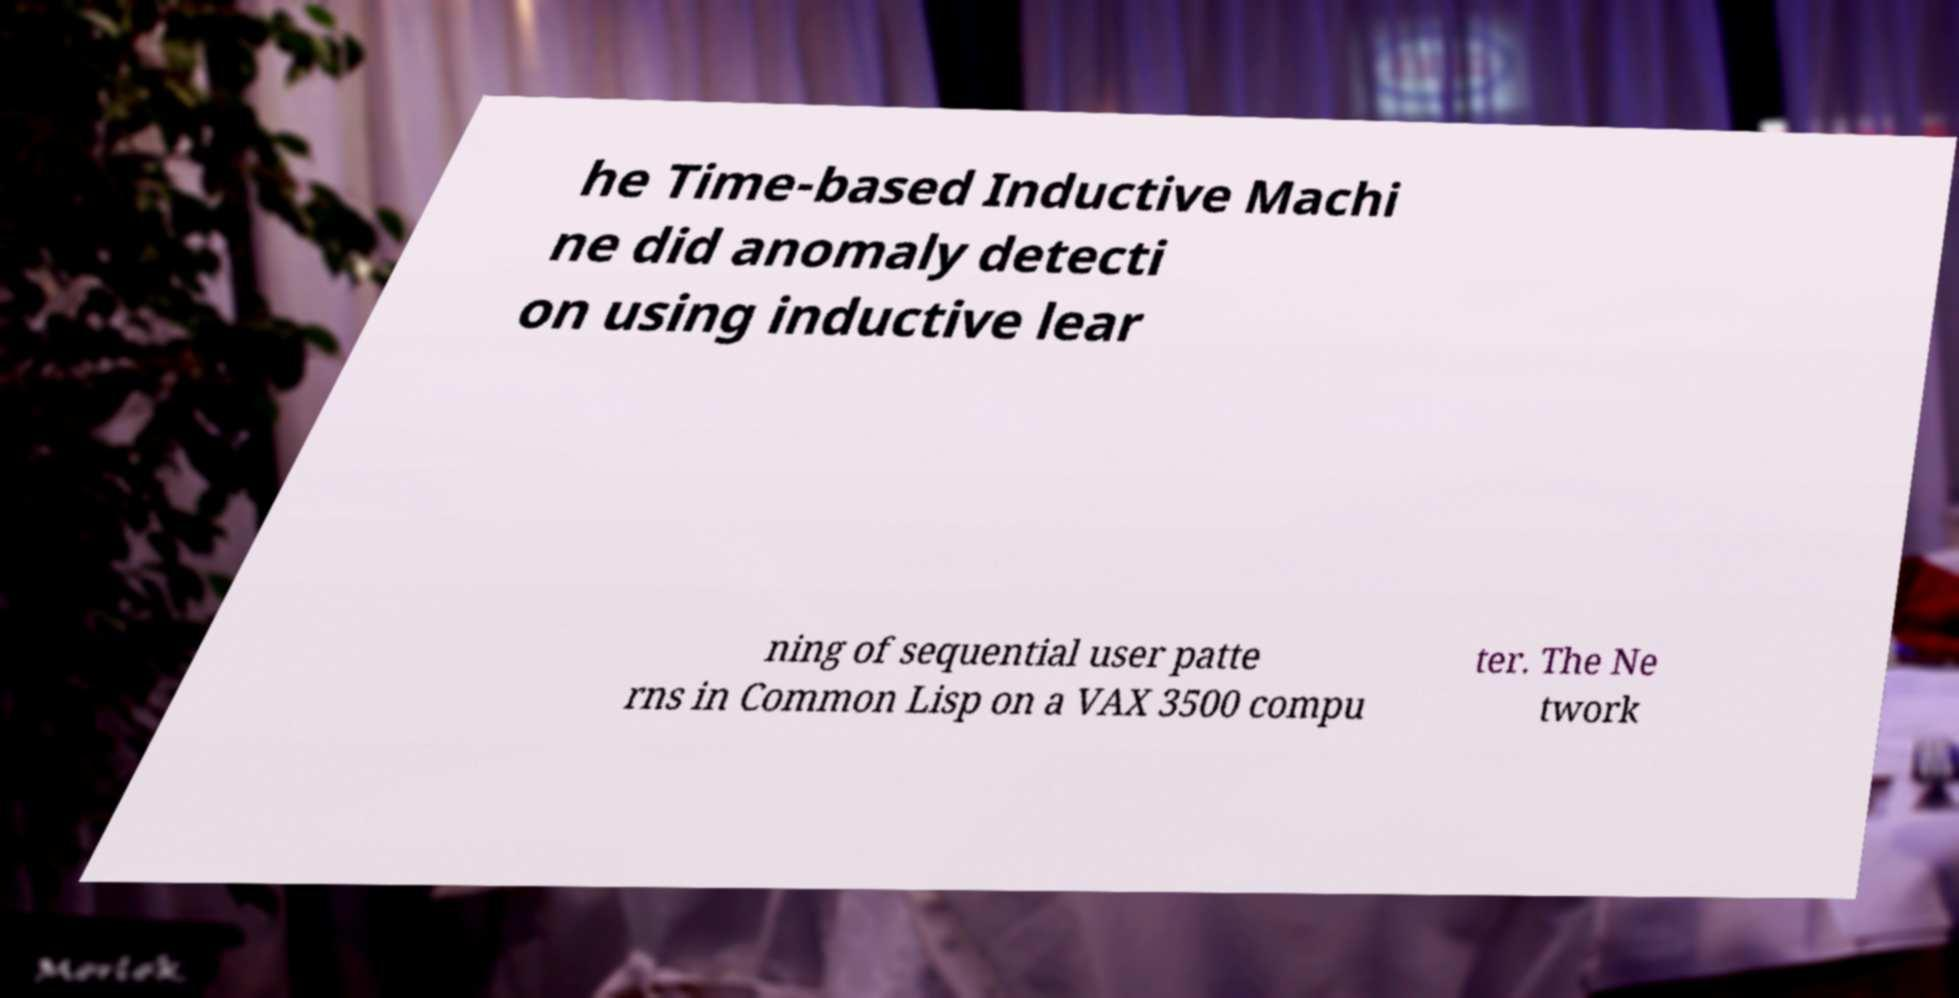Please identify and transcribe the text found in this image. he Time-based Inductive Machi ne did anomaly detecti on using inductive lear ning of sequential user patte rns in Common Lisp on a VAX 3500 compu ter. The Ne twork 